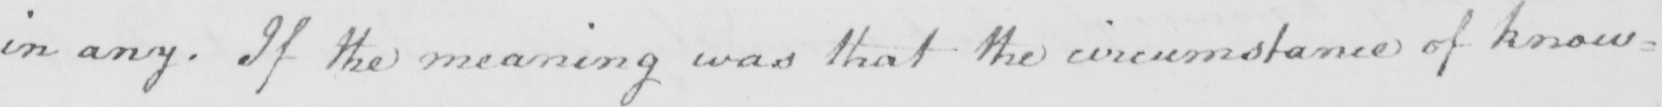Transcribe the text shown in this historical manuscript line. in any . If the meaning was that the circumstance of know= 